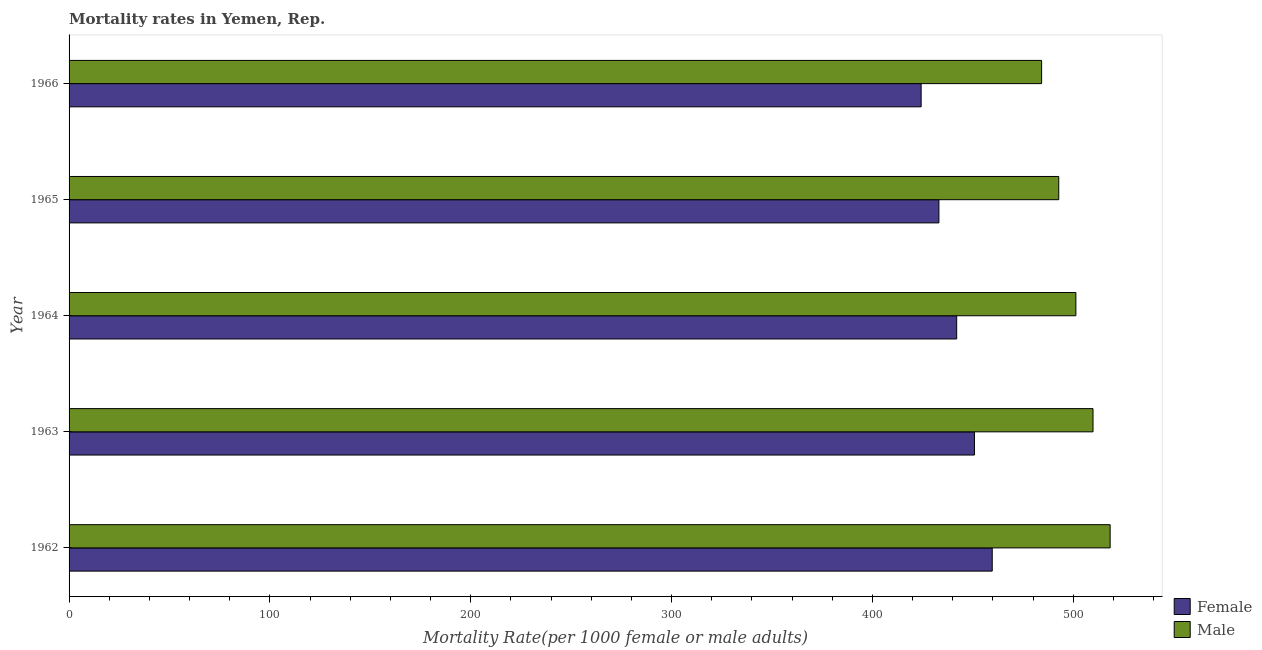Are the number of bars per tick equal to the number of legend labels?
Your answer should be very brief. Yes. How many bars are there on the 2nd tick from the top?
Make the answer very short. 2. How many bars are there on the 1st tick from the bottom?
Provide a succinct answer. 2. What is the label of the 4th group of bars from the top?
Your answer should be very brief. 1963. In how many cases, is the number of bars for a given year not equal to the number of legend labels?
Your answer should be compact. 0. What is the male mortality rate in 1965?
Keep it short and to the point. 492.75. Across all years, what is the maximum male mortality rate?
Provide a succinct answer. 518.34. Across all years, what is the minimum male mortality rate?
Ensure brevity in your answer.  484.22. In which year was the male mortality rate maximum?
Provide a short and direct response. 1962. In which year was the male mortality rate minimum?
Provide a succinct answer. 1966. What is the total female mortality rate in the graph?
Your answer should be very brief. 2209.69. What is the difference between the female mortality rate in 1962 and that in 1963?
Ensure brevity in your answer.  8.85. What is the difference between the male mortality rate in 1963 and the female mortality rate in 1965?
Ensure brevity in your answer.  76.72. What is the average male mortality rate per year?
Your response must be concise. 501.28. In the year 1965, what is the difference between the male mortality rate and female mortality rate?
Your answer should be compact. 59.66. What is the ratio of the female mortality rate in 1962 to that in 1963?
Offer a terse response. 1.02. Is the difference between the male mortality rate in 1965 and 1966 greater than the difference between the female mortality rate in 1965 and 1966?
Keep it short and to the point. No. What is the difference between the highest and the second highest female mortality rate?
Keep it short and to the point. 8.85. What is the difference between the highest and the lowest female mortality rate?
Your answer should be compact. 35.39. How many bars are there?
Provide a short and direct response. 10. What is the difference between two consecutive major ticks on the X-axis?
Give a very brief answer. 100. Are the values on the major ticks of X-axis written in scientific E-notation?
Your response must be concise. No. Does the graph contain any zero values?
Your response must be concise. No. Does the graph contain grids?
Your answer should be compact. No. Where does the legend appear in the graph?
Give a very brief answer. Bottom right. How many legend labels are there?
Your answer should be very brief. 2. What is the title of the graph?
Make the answer very short. Mortality rates in Yemen, Rep. What is the label or title of the X-axis?
Offer a very short reply. Mortality Rate(per 1000 female or male adults). What is the label or title of the Y-axis?
Your answer should be compact. Year. What is the Mortality Rate(per 1000 female or male adults) in Female in 1962?
Offer a very short reply. 459.63. What is the Mortality Rate(per 1000 female or male adults) in Male in 1962?
Your answer should be compact. 518.34. What is the Mortality Rate(per 1000 female or male adults) in Female in 1963?
Ensure brevity in your answer.  450.79. What is the Mortality Rate(per 1000 female or male adults) of Male in 1963?
Your answer should be very brief. 509.81. What is the Mortality Rate(per 1000 female or male adults) of Female in 1964?
Your response must be concise. 441.94. What is the Mortality Rate(per 1000 female or male adults) of Male in 1964?
Provide a short and direct response. 501.28. What is the Mortality Rate(per 1000 female or male adults) of Female in 1965?
Your response must be concise. 433.09. What is the Mortality Rate(per 1000 female or male adults) in Male in 1965?
Your answer should be compact. 492.75. What is the Mortality Rate(per 1000 female or male adults) of Female in 1966?
Your answer should be very brief. 424.24. What is the Mortality Rate(per 1000 female or male adults) of Male in 1966?
Your response must be concise. 484.22. Across all years, what is the maximum Mortality Rate(per 1000 female or male adults) of Female?
Offer a very short reply. 459.63. Across all years, what is the maximum Mortality Rate(per 1000 female or male adults) of Male?
Provide a succinct answer. 518.34. Across all years, what is the minimum Mortality Rate(per 1000 female or male adults) of Female?
Ensure brevity in your answer.  424.24. Across all years, what is the minimum Mortality Rate(per 1000 female or male adults) of Male?
Offer a very short reply. 484.22. What is the total Mortality Rate(per 1000 female or male adults) in Female in the graph?
Your answer should be very brief. 2209.69. What is the total Mortality Rate(per 1000 female or male adults) in Male in the graph?
Ensure brevity in your answer.  2506.41. What is the difference between the Mortality Rate(per 1000 female or male adults) in Female in 1962 and that in 1963?
Ensure brevity in your answer.  8.85. What is the difference between the Mortality Rate(per 1000 female or male adults) of Male in 1962 and that in 1963?
Your response must be concise. 8.53. What is the difference between the Mortality Rate(per 1000 female or male adults) of Female in 1962 and that in 1964?
Offer a very short reply. 17.7. What is the difference between the Mortality Rate(per 1000 female or male adults) of Male in 1962 and that in 1964?
Make the answer very short. 17.06. What is the difference between the Mortality Rate(per 1000 female or male adults) in Female in 1962 and that in 1965?
Your answer should be compact. 26.55. What is the difference between the Mortality Rate(per 1000 female or male adults) in Male in 1962 and that in 1965?
Provide a short and direct response. 25.59. What is the difference between the Mortality Rate(per 1000 female or male adults) in Female in 1962 and that in 1966?
Your response must be concise. 35.39. What is the difference between the Mortality Rate(per 1000 female or male adults) in Male in 1962 and that in 1966?
Ensure brevity in your answer.  34.12. What is the difference between the Mortality Rate(per 1000 female or male adults) in Female in 1963 and that in 1964?
Ensure brevity in your answer.  8.85. What is the difference between the Mortality Rate(per 1000 female or male adults) of Male in 1963 and that in 1964?
Provide a succinct answer. 8.53. What is the difference between the Mortality Rate(per 1000 female or male adults) in Female in 1963 and that in 1965?
Your answer should be very brief. 17.7. What is the difference between the Mortality Rate(per 1000 female or male adults) of Male in 1963 and that in 1965?
Offer a very short reply. 17.06. What is the difference between the Mortality Rate(per 1000 female or male adults) of Female in 1963 and that in 1966?
Ensure brevity in your answer.  26.55. What is the difference between the Mortality Rate(per 1000 female or male adults) of Male in 1963 and that in 1966?
Provide a succinct answer. 25.59. What is the difference between the Mortality Rate(per 1000 female or male adults) in Female in 1964 and that in 1965?
Keep it short and to the point. 8.85. What is the difference between the Mortality Rate(per 1000 female or male adults) in Male in 1964 and that in 1965?
Your answer should be compact. 8.53. What is the difference between the Mortality Rate(per 1000 female or male adults) of Female in 1964 and that in 1966?
Make the answer very short. 17.7. What is the difference between the Mortality Rate(per 1000 female or male adults) of Male in 1964 and that in 1966?
Your response must be concise. 17.06. What is the difference between the Mortality Rate(per 1000 female or male adults) in Female in 1965 and that in 1966?
Provide a succinct answer. 8.85. What is the difference between the Mortality Rate(per 1000 female or male adults) in Male in 1965 and that in 1966?
Offer a very short reply. 8.53. What is the difference between the Mortality Rate(per 1000 female or male adults) in Female in 1962 and the Mortality Rate(per 1000 female or male adults) in Male in 1963?
Keep it short and to the point. -50.18. What is the difference between the Mortality Rate(per 1000 female or male adults) of Female in 1962 and the Mortality Rate(per 1000 female or male adults) of Male in 1964?
Ensure brevity in your answer.  -41.65. What is the difference between the Mortality Rate(per 1000 female or male adults) in Female in 1962 and the Mortality Rate(per 1000 female or male adults) in Male in 1965?
Offer a terse response. -33.12. What is the difference between the Mortality Rate(per 1000 female or male adults) in Female in 1962 and the Mortality Rate(per 1000 female or male adults) in Male in 1966?
Ensure brevity in your answer.  -24.59. What is the difference between the Mortality Rate(per 1000 female or male adults) in Female in 1963 and the Mortality Rate(per 1000 female or male adults) in Male in 1964?
Your answer should be compact. -50.49. What is the difference between the Mortality Rate(per 1000 female or male adults) in Female in 1963 and the Mortality Rate(per 1000 female or male adults) in Male in 1965?
Give a very brief answer. -41.97. What is the difference between the Mortality Rate(per 1000 female or male adults) in Female in 1963 and the Mortality Rate(per 1000 female or male adults) in Male in 1966?
Make the answer very short. -33.44. What is the difference between the Mortality Rate(per 1000 female or male adults) of Female in 1964 and the Mortality Rate(per 1000 female or male adults) of Male in 1965?
Keep it short and to the point. -50.81. What is the difference between the Mortality Rate(per 1000 female or male adults) in Female in 1964 and the Mortality Rate(per 1000 female or male adults) in Male in 1966?
Your answer should be compact. -42.28. What is the difference between the Mortality Rate(per 1000 female or male adults) in Female in 1965 and the Mortality Rate(per 1000 female or male adults) in Male in 1966?
Offer a terse response. -51.13. What is the average Mortality Rate(per 1000 female or male adults) in Female per year?
Your answer should be compact. 441.94. What is the average Mortality Rate(per 1000 female or male adults) of Male per year?
Your response must be concise. 501.28. In the year 1962, what is the difference between the Mortality Rate(per 1000 female or male adults) of Female and Mortality Rate(per 1000 female or male adults) of Male?
Your answer should be compact. -58.71. In the year 1963, what is the difference between the Mortality Rate(per 1000 female or male adults) of Female and Mortality Rate(per 1000 female or male adults) of Male?
Your answer should be compact. -59.02. In the year 1964, what is the difference between the Mortality Rate(per 1000 female or male adults) in Female and Mortality Rate(per 1000 female or male adults) in Male?
Ensure brevity in your answer.  -59.34. In the year 1965, what is the difference between the Mortality Rate(per 1000 female or male adults) of Female and Mortality Rate(per 1000 female or male adults) of Male?
Make the answer very short. -59.66. In the year 1966, what is the difference between the Mortality Rate(per 1000 female or male adults) of Female and Mortality Rate(per 1000 female or male adults) of Male?
Your answer should be very brief. -59.98. What is the ratio of the Mortality Rate(per 1000 female or male adults) in Female in 1962 to that in 1963?
Provide a succinct answer. 1.02. What is the ratio of the Mortality Rate(per 1000 female or male adults) in Male in 1962 to that in 1963?
Keep it short and to the point. 1.02. What is the ratio of the Mortality Rate(per 1000 female or male adults) in Male in 1962 to that in 1964?
Make the answer very short. 1.03. What is the ratio of the Mortality Rate(per 1000 female or male adults) of Female in 1962 to that in 1965?
Make the answer very short. 1.06. What is the ratio of the Mortality Rate(per 1000 female or male adults) of Male in 1962 to that in 1965?
Your answer should be very brief. 1.05. What is the ratio of the Mortality Rate(per 1000 female or male adults) of Female in 1962 to that in 1966?
Provide a short and direct response. 1.08. What is the ratio of the Mortality Rate(per 1000 female or male adults) of Male in 1962 to that in 1966?
Offer a very short reply. 1.07. What is the ratio of the Mortality Rate(per 1000 female or male adults) in Female in 1963 to that in 1964?
Your answer should be very brief. 1.02. What is the ratio of the Mortality Rate(per 1000 female or male adults) of Male in 1963 to that in 1964?
Offer a very short reply. 1.02. What is the ratio of the Mortality Rate(per 1000 female or male adults) of Female in 1963 to that in 1965?
Keep it short and to the point. 1.04. What is the ratio of the Mortality Rate(per 1000 female or male adults) of Male in 1963 to that in 1965?
Your answer should be compact. 1.03. What is the ratio of the Mortality Rate(per 1000 female or male adults) of Female in 1963 to that in 1966?
Make the answer very short. 1.06. What is the ratio of the Mortality Rate(per 1000 female or male adults) of Male in 1963 to that in 1966?
Keep it short and to the point. 1.05. What is the ratio of the Mortality Rate(per 1000 female or male adults) in Female in 1964 to that in 1965?
Keep it short and to the point. 1.02. What is the ratio of the Mortality Rate(per 1000 female or male adults) of Male in 1964 to that in 1965?
Your answer should be compact. 1.02. What is the ratio of the Mortality Rate(per 1000 female or male adults) of Female in 1964 to that in 1966?
Offer a terse response. 1.04. What is the ratio of the Mortality Rate(per 1000 female or male adults) of Male in 1964 to that in 1966?
Give a very brief answer. 1.04. What is the ratio of the Mortality Rate(per 1000 female or male adults) of Female in 1965 to that in 1966?
Your answer should be compact. 1.02. What is the ratio of the Mortality Rate(per 1000 female or male adults) in Male in 1965 to that in 1966?
Keep it short and to the point. 1.02. What is the difference between the highest and the second highest Mortality Rate(per 1000 female or male adults) of Female?
Your answer should be compact. 8.85. What is the difference between the highest and the second highest Mortality Rate(per 1000 female or male adults) of Male?
Offer a very short reply. 8.53. What is the difference between the highest and the lowest Mortality Rate(per 1000 female or male adults) of Female?
Offer a very short reply. 35.39. What is the difference between the highest and the lowest Mortality Rate(per 1000 female or male adults) in Male?
Offer a very short reply. 34.12. 